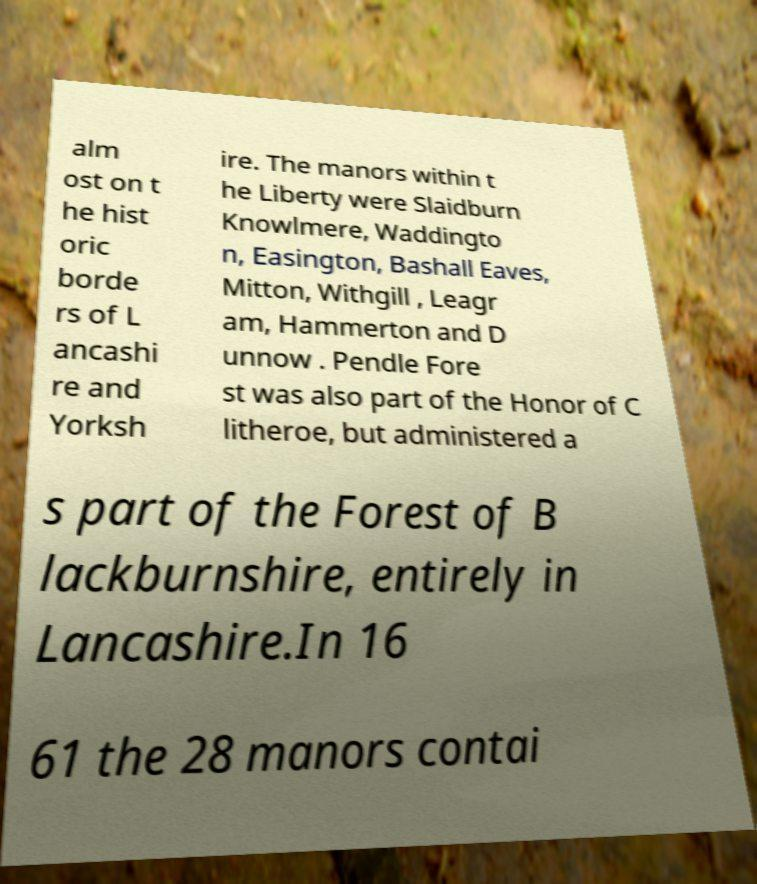Can you accurately transcribe the text from the provided image for me? alm ost on t he hist oric borde rs of L ancashi re and Yorksh ire. The manors within t he Liberty were Slaidburn Knowlmere, Waddingto n, Easington, Bashall Eaves, Mitton, Withgill , Leagr am, Hammerton and D unnow . Pendle Fore st was also part of the Honor of C litheroe, but administered a s part of the Forest of B lackburnshire, entirely in Lancashire.In 16 61 the 28 manors contai 